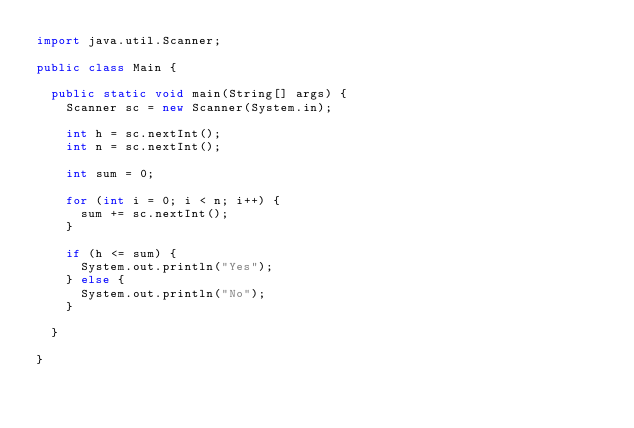<code> <loc_0><loc_0><loc_500><loc_500><_Java_>import java.util.Scanner;

public class Main {

  public static void main(String[] args) {
    Scanner sc = new Scanner(System.in);

    int h = sc.nextInt();
    int n = sc.nextInt();

    int sum = 0;

    for (int i = 0; i < n; i++) {
      sum += sc.nextInt();
    }

    if (h <= sum) {
      System.out.println("Yes");
    } else {
      System.out.println("No");
    }

  }

}
</code> 